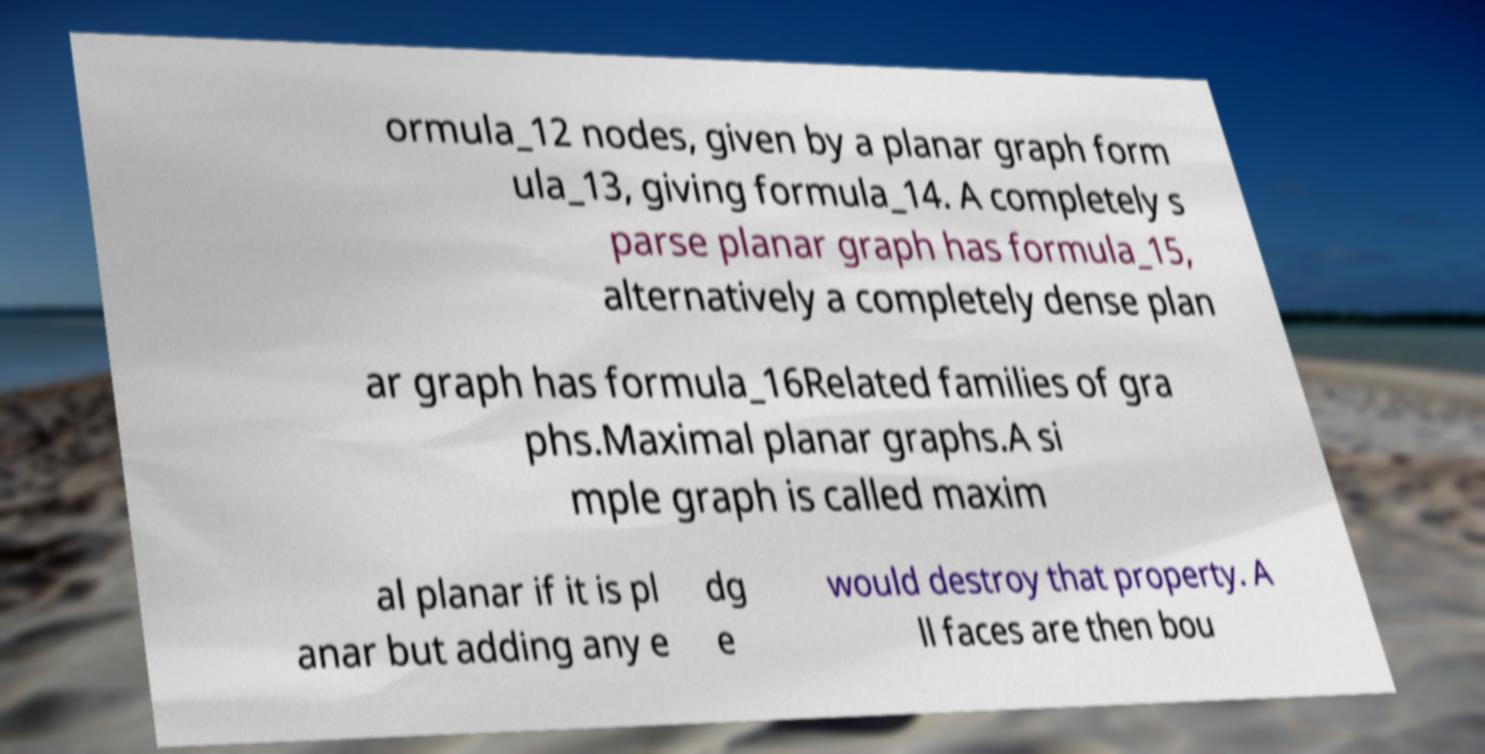There's text embedded in this image that I need extracted. Can you transcribe it verbatim? ormula_12 nodes, given by a planar graph form ula_13, giving formula_14. A completely s parse planar graph has formula_15, alternatively a completely dense plan ar graph has formula_16Related families of gra phs.Maximal planar graphs.A si mple graph is called maxim al planar if it is pl anar but adding any e dg e would destroy that property. A ll faces are then bou 